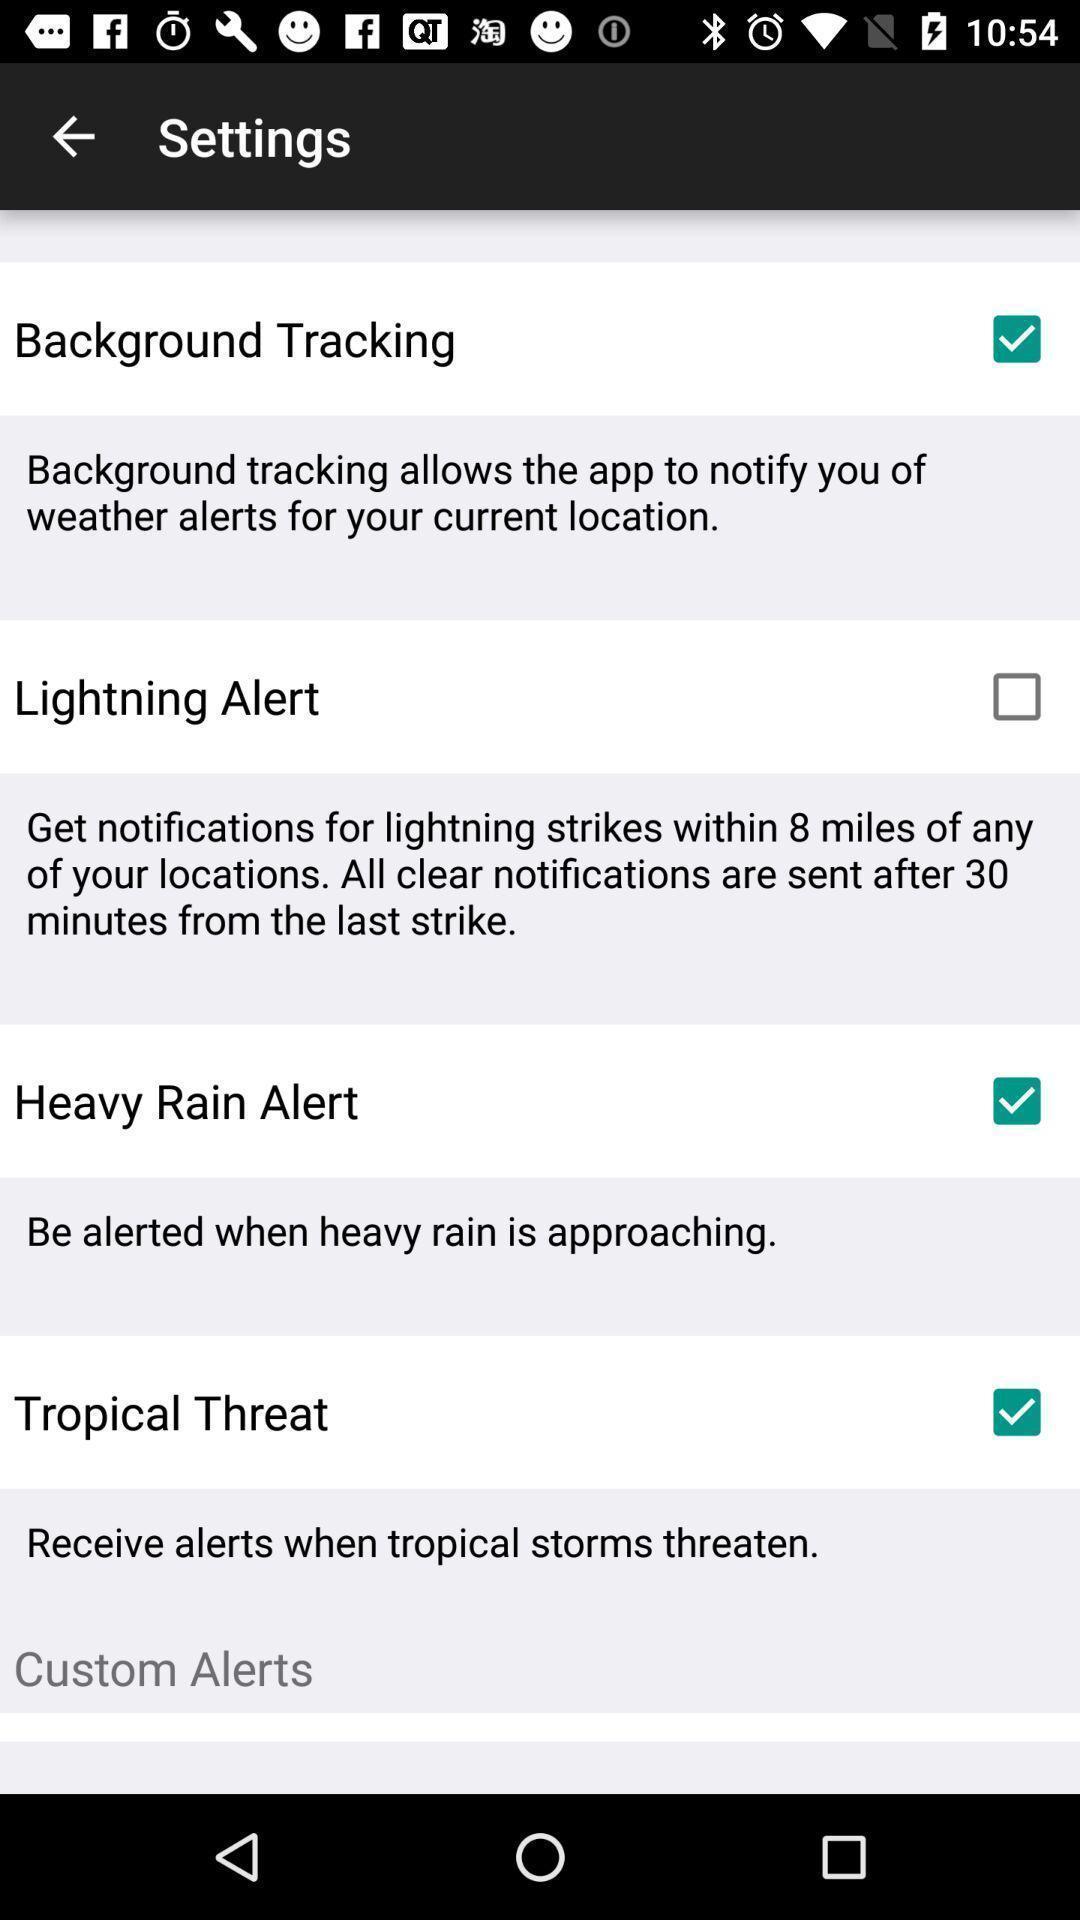What can you discern from this picture? Screen showing the options in black page. 